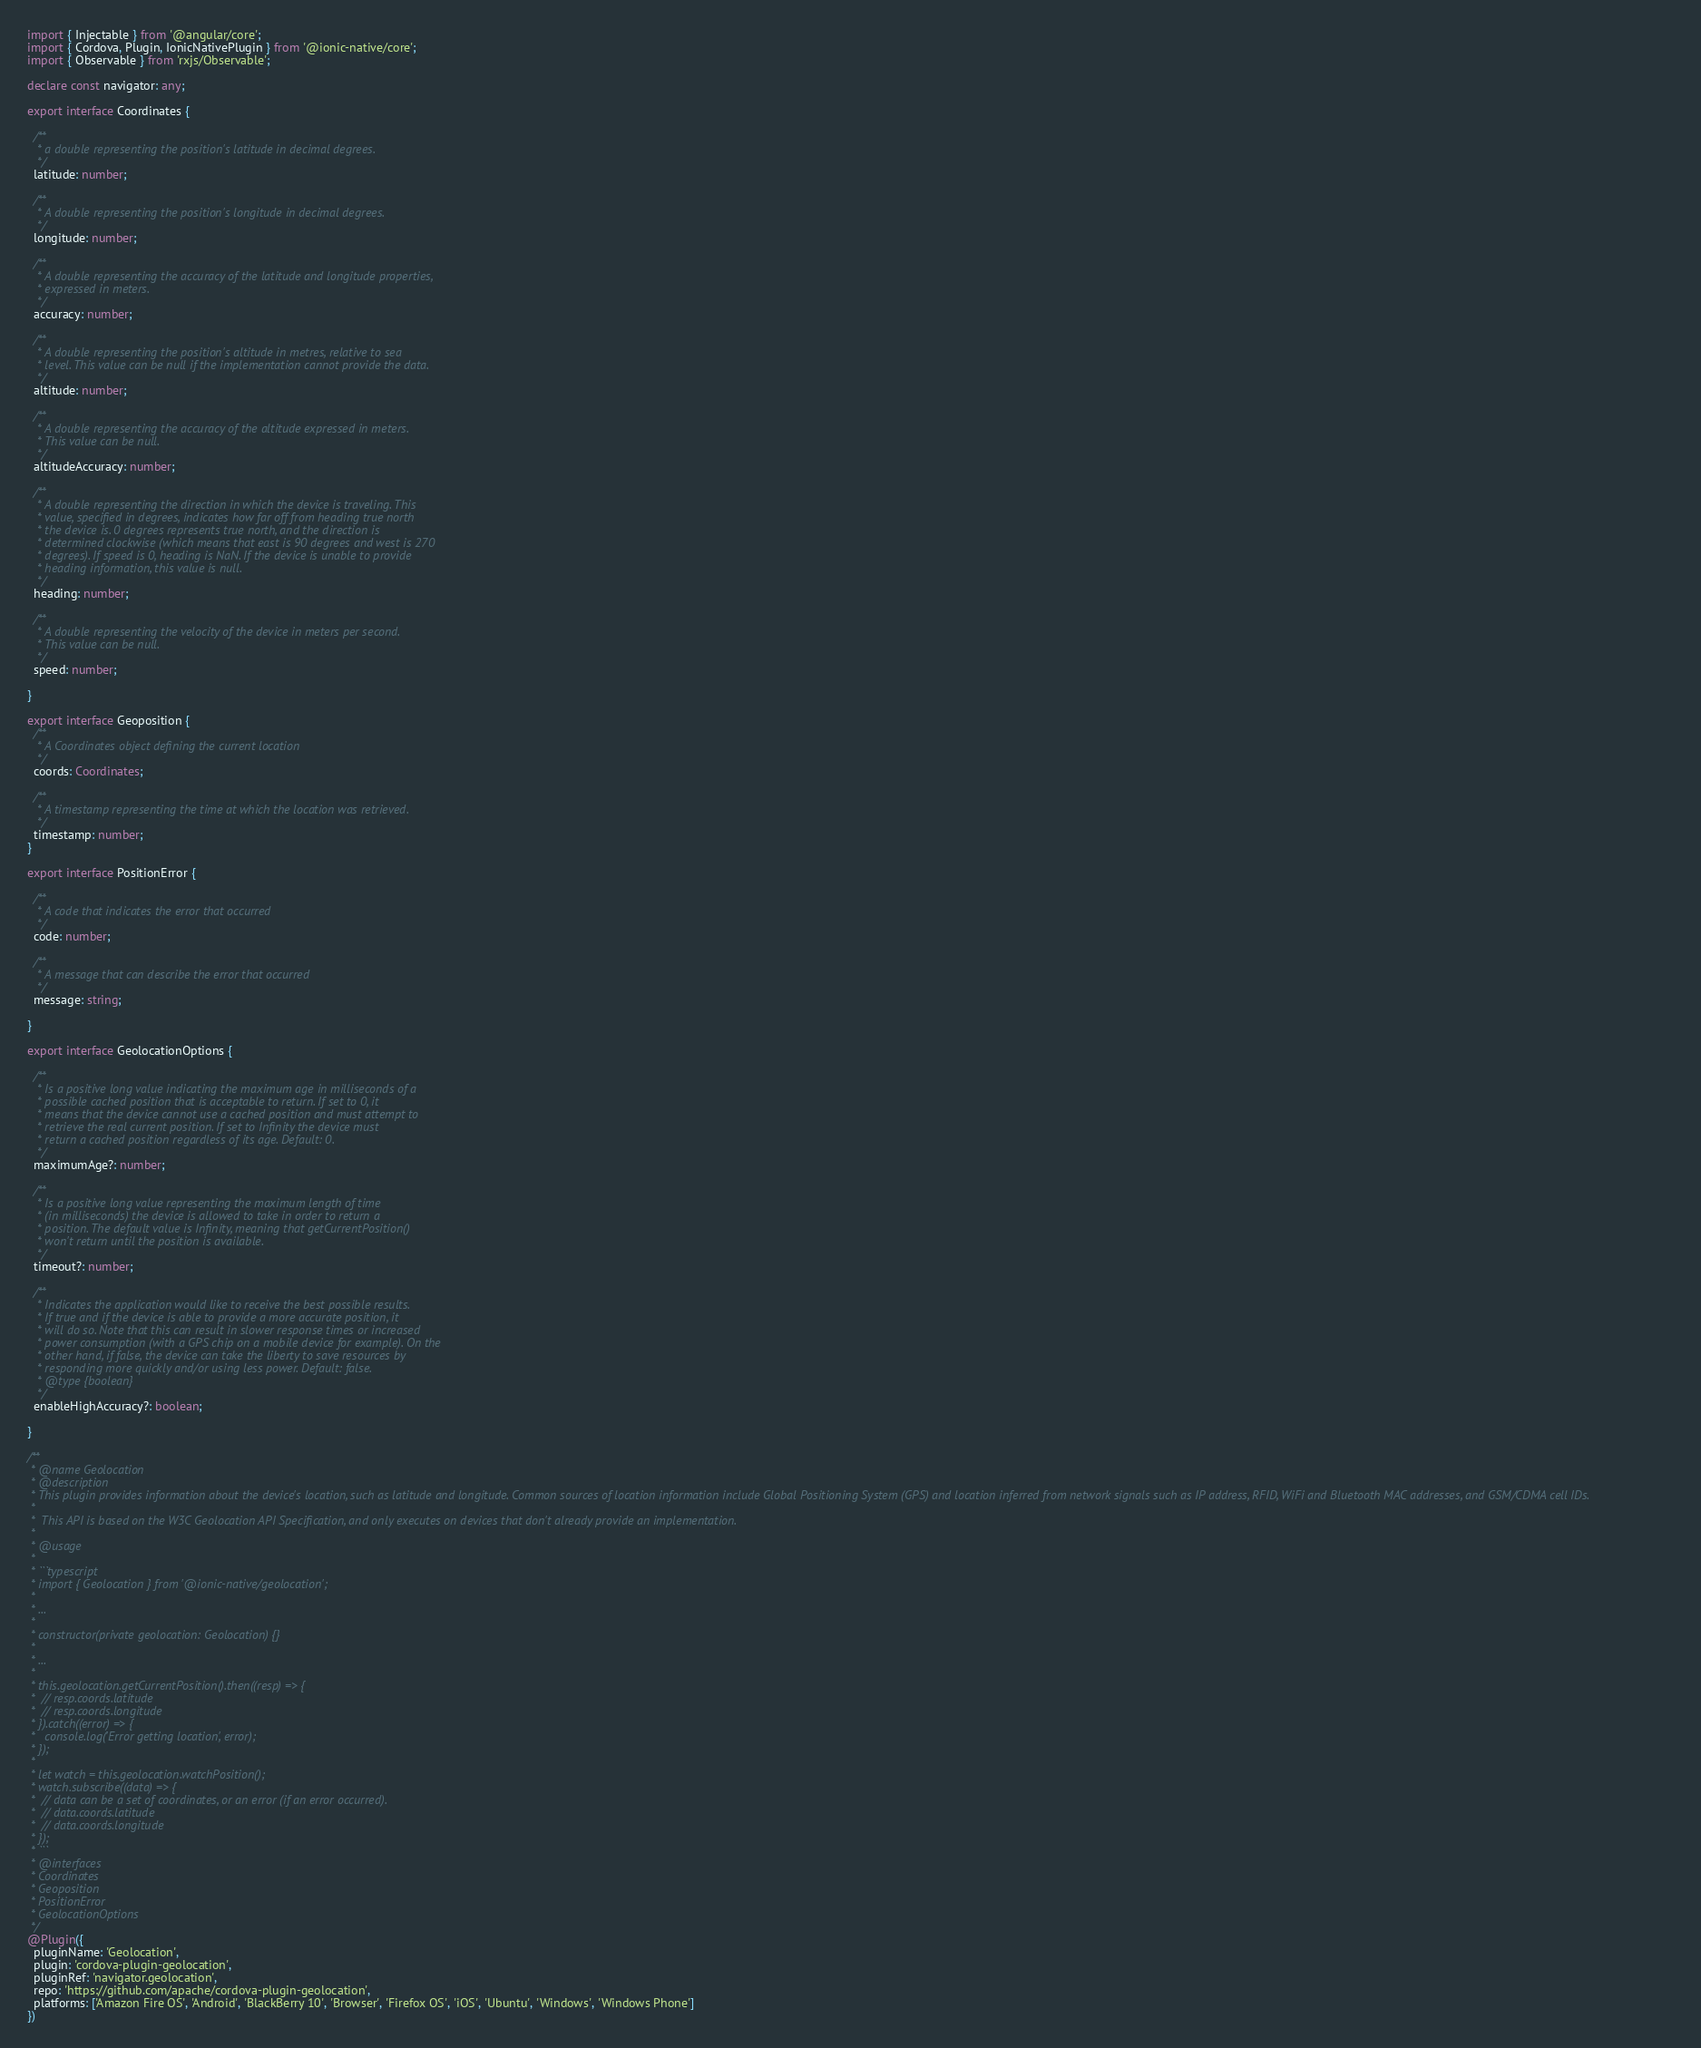Convert code to text. <code><loc_0><loc_0><loc_500><loc_500><_TypeScript_>import { Injectable } from '@angular/core';
import { Cordova, Plugin, IonicNativePlugin } from '@ionic-native/core';
import { Observable } from 'rxjs/Observable';

declare const navigator: any;

export interface Coordinates {

  /**
   * a double representing the position's latitude in decimal degrees.
   */
  latitude: number;

  /**
   * A double representing the position's longitude in decimal degrees.
   */
  longitude: number;

  /**
   * A double representing the accuracy of the latitude and longitude properties,
   * expressed in meters.
   */
  accuracy: number;

  /**
   * A double representing the position's altitude in metres, relative to sea
   * level. This value can be null if the implementation cannot provide the data.
   */
  altitude: number;

  /**
   * A double representing the accuracy of the altitude expressed in meters.
   * This value can be null.
   */
  altitudeAccuracy: number;

  /**
   * A double representing the direction in which the device is traveling. This
   * value, specified in degrees, indicates how far off from heading true north
   * the device is. 0 degrees represents true north, and the direction is
   * determined clockwise (which means that east is 90 degrees and west is 270
   * degrees). If speed is 0, heading is NaN. If the device is unable to provide
   * heading information, this value is null.
   */
  heading: number;

  /**
   * A double representing the velocity of the device in meters per second.
   * This value can be null.
   */
  speed: number;

}

export interface Geoposition {
  /**
   * A Coordinates object defining the current location
   */
  coords: Coordinates;

  /**
   * A timestamp representing the time at which the location was retrieved.
   */
  timestamp: number;
}

export interface PositionError {

  /**
   * A code that indicates the error that occurred
   */
  code: number;

  /**
   * A message that can describe the error that occurred
   */
  message: string;

}

export interface GeolocationOptions {

  /**
   * Is a positive long value indicating the maximum age in milliseconds of a
   * possible cached position that is acceptable to return. If set to 0, it
   * means that the device cannot use a cached position and must attempt to
   * retrieve the real current position. If set to Infinity the device must
   * return a cached position regardless of its age. Default: 0.
   */
  maximumAge?: number;

  /**
   * Is a positive long value representing the maximum length of time
   * (in milliseconds) the device is allowed to take in order to return a
   * position. The default value is Infinity, meaning that getCurrentPosition()
   * won't return until the position is available.
   */
  timeout?: number;

  /**
   * Indicates the application would like to receive the best possible results.
   * If true and if the device is able to provide a more accurate position, it
   * will do so. Note that this can result in slower response times or increased
   * power consumption (with a GPS chip on a mobile device for example). On the
   * other hand, if false, the device can take the liberty to save resources by
   * responding more quickly and/or using less power. Default: false.
   * @type {boolean}
   */
  enableHighAccuracy?: boolean;

}

/**
 * @name Geolocation
 * @description
 * This plugin provides information about the device's location, such as latitude and longitude. Common sources of location information include Global Positioning System (GPS) and location inferred from network signals such as IP address, RFID, WiFi and Bluetooth MAC addresses, and GSM/CDMA cell IDs.
 *
 *  This API is based on the W3C Geolocation API Specification, and only executes on devices that don't already provide an implementation.
 *
 * @usage
 *
 * ```typescript
 * import { Geolocation } from '@ionic-native/geolocation';
 *
 * ...
 *
 * constructor(private geolocation: Geolocation) {}
 *
 * ...
 *
 * this.geolocation.getCurrentPosition().then((resp) => {
 *  // resp.coords.latitude
 *  // resp.coords.longitude
 * }).catch((error) => {
 *   console.log('Error getting location', error);
 * });
 *
 * let watch = this.geolocation.watchPosition();
 * watch.subscribe((data) => {
 *  // data can be a set of coordinates, or an error (if an error occurred).
 *  // data.coords.latitude
 *  // data.coords.longitude
 * });
 * ```
 * @interfaces
 * Coordinates
 * Geoposition
 * PositionError
 * GeolocationOptions
 */
@Plugin({
  pluginName: 'Geolocation',
  plugin: 'cordova-plugin-geolocation',
  pluginRef: 'navigator.geolocation',
  repo: 'https://github.com/apache/cordova-plugin-geolocation',
  platforms: ['Amazon Fire OS', 'Android', 'BlackBerry 10', 'Browser', 'Firefox OS', 'iOS', 'Ubuntu', 'Windows', 'Windows Phone']
})</code> 